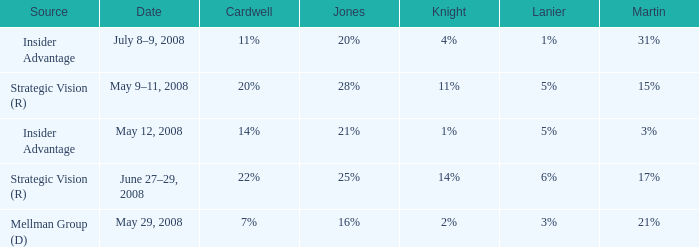What cardwell has an insider advantage and a knight of 1% 14%. 